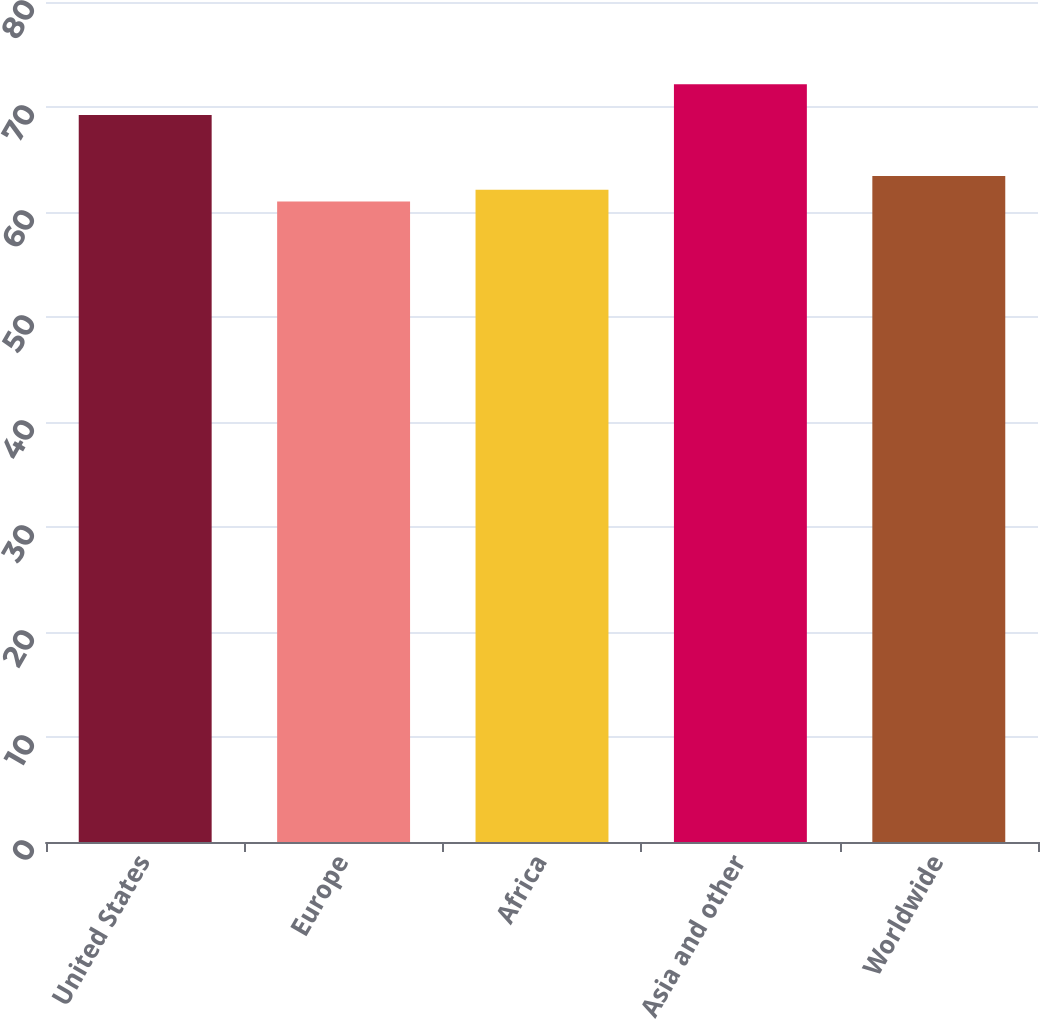Convert chart. <chart><loc_0><loc_0><loc_500><loc_500><bar_chart><fcel>United States<fcel>Europe<fcel>Africa<fcel>Asia and other<fcel>Worldwide<nl><fcel>69.23<fcel>60.99<fcel>62.11<fcel>72.17<fcel>63.44<nl></chart> 